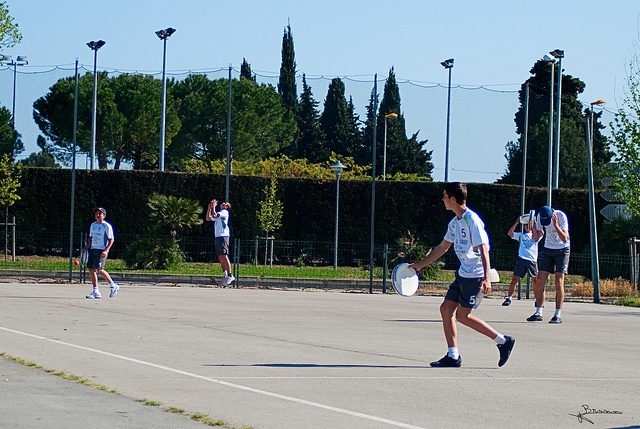Describe the objects in this image and their specific colors. I can see people in lightblue, black, maroon, darkgray, and lightgray tones, people in lightblue, black, maroon, darkgray, and lightgray tones, people in lightblue, black, darkgray, lightgray, and gray tones, people in lightblue, black, white, gray, and maroon tones, and people in lightblue, black, maroon, gray, and lavender tones in this image. 